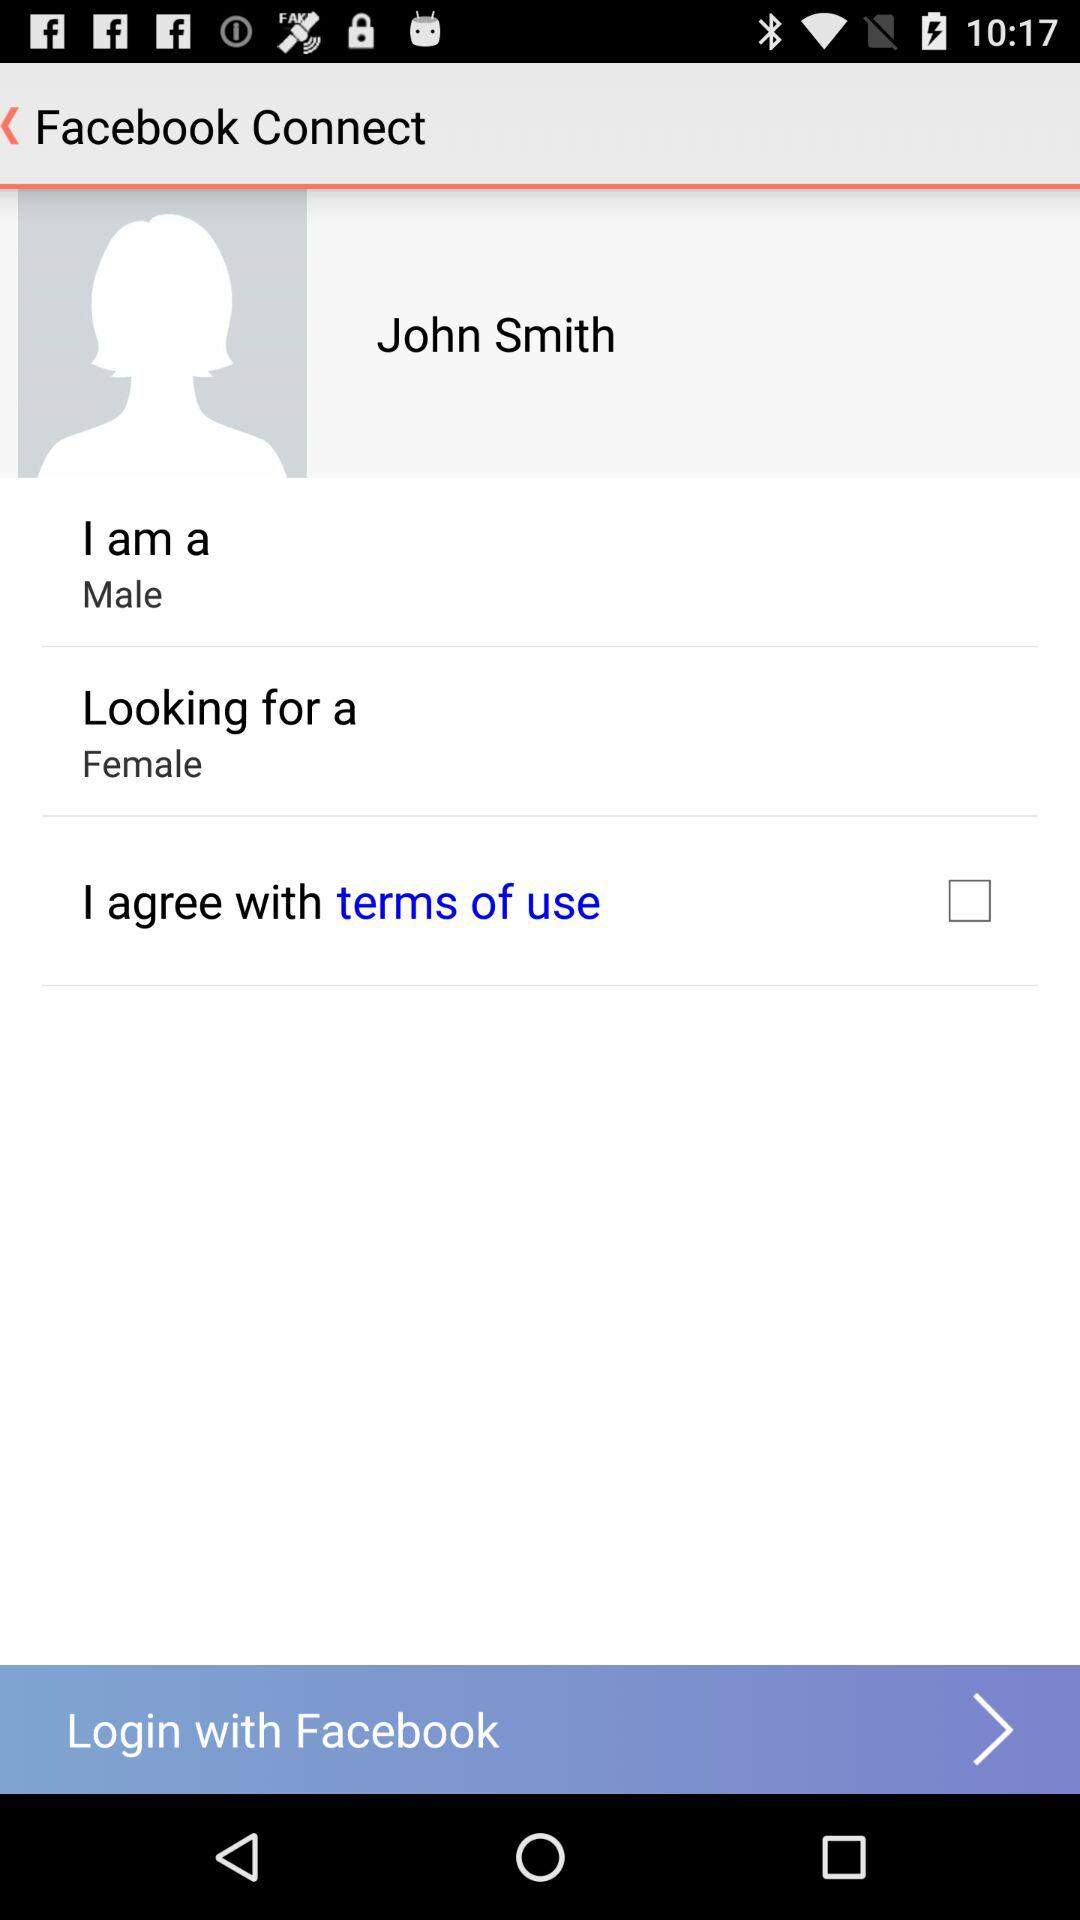What is the gender of the user? The gender of the user is male. 